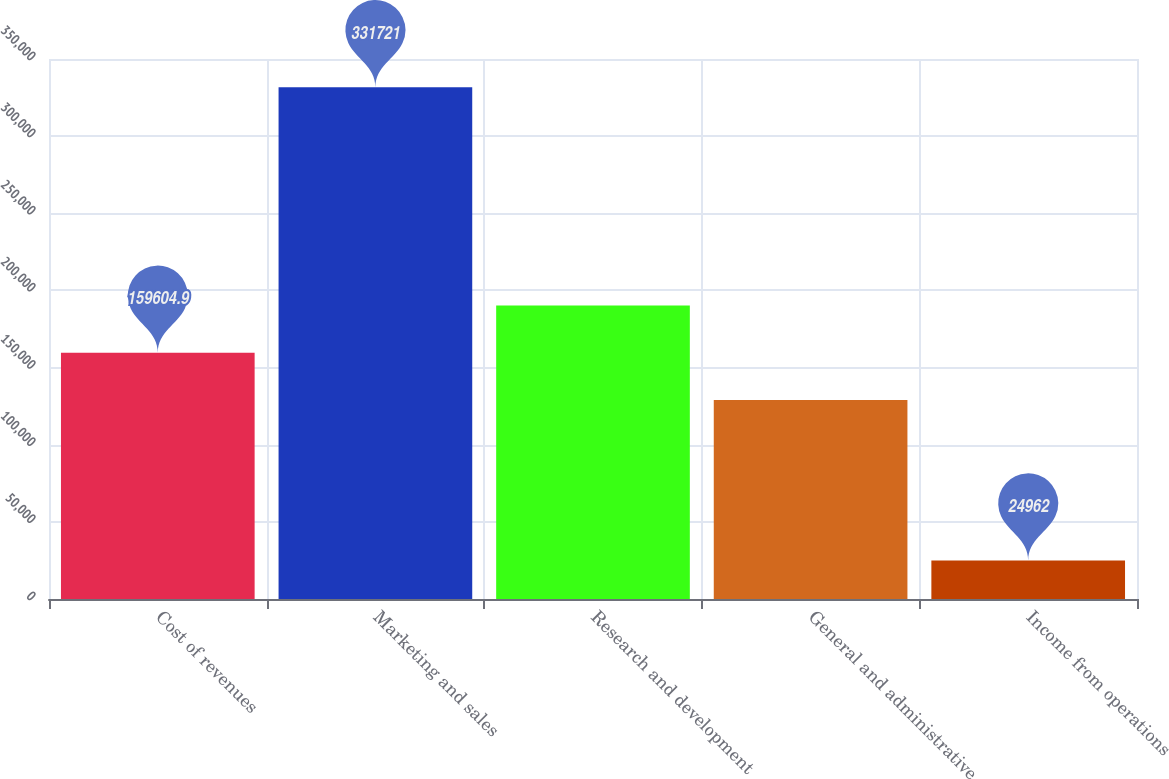<chart> <loc_0><loc_0><loc_500><loc_500><bar_chart><fcel>Cost of revenues<fcel>Marketing and sales<fcel>Research and development<fcel>General and administrative<fcel>Income from operations<nl><fcel>159605<fcel>331721<fcel>190281<fcel>128929<fcel>24962<nl></chart> 